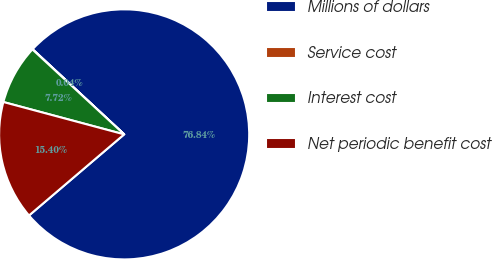Convert chart. <chart><loc_0><loc_0><loc_500><loc_500><pie_chart><fcel>Millions of dollars<fcel>Service cost<fcel>Interest cost<fcel>Net periodic benefit cost<nl><fcel>76.84%<fcel>0.04%<fcel>7.72%<fcel>15.4%<nl></chart> 